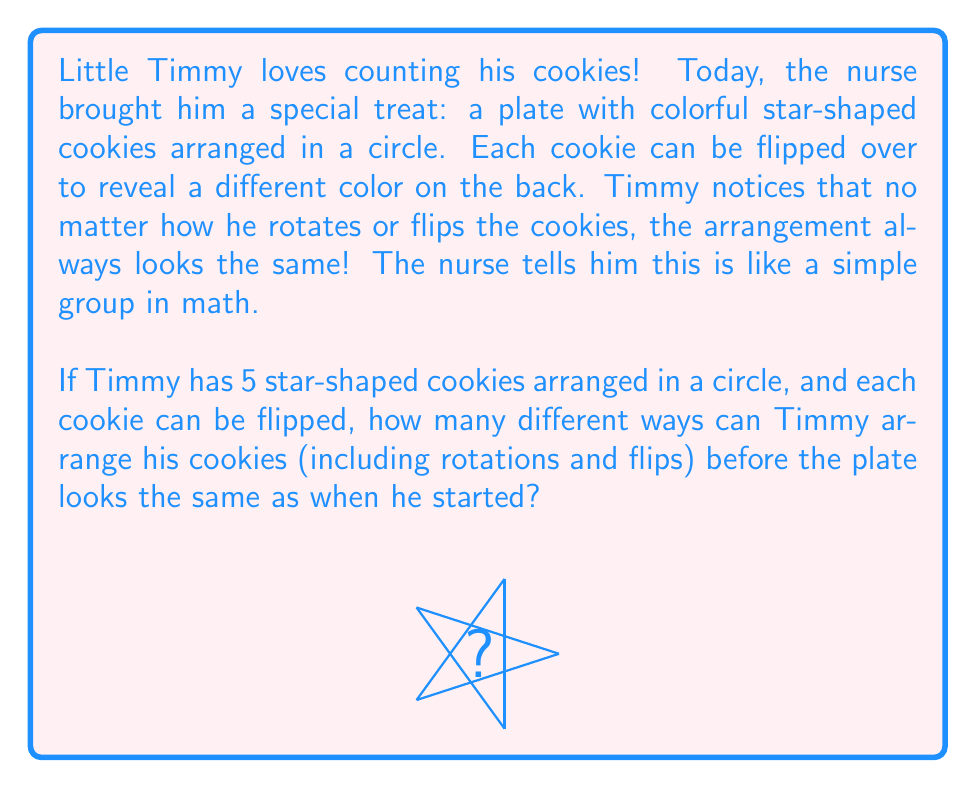Give your solution to this math problem. Let's help Timmy count the arrangements step-by-step:

1) First, we need to recognize that this arrangement forms a dihedral group $D_5$, which is a simple group.

2) The order of a dihedral group $D_n$ is given by the formula:

   $$|D_n| = 2n$$

3) In this case, $n = 5$ (because there are 5 cookies), so we calculate:

   $$|D_5| = 2 \cdot 5 = 10$$

4) This means there are 10 elements in the group, which correspond to:
   - 5 rotations (including the identity rotation)
   - 5 reflections (flips)

5) We can break it down for Timmy:
   - He can rotate the plate 5 different ways (0°, 72°, 144°, 216°, 288°)
   - For each of these rotations, he can either leave it as is or flip all cookies

6) This gives us a total of 5 * 2 = 10 different arrangements.

So, there are 10 different ways Timmy can arrange his cookies before the plate looks the same as when he started.
Answer: $10$ 